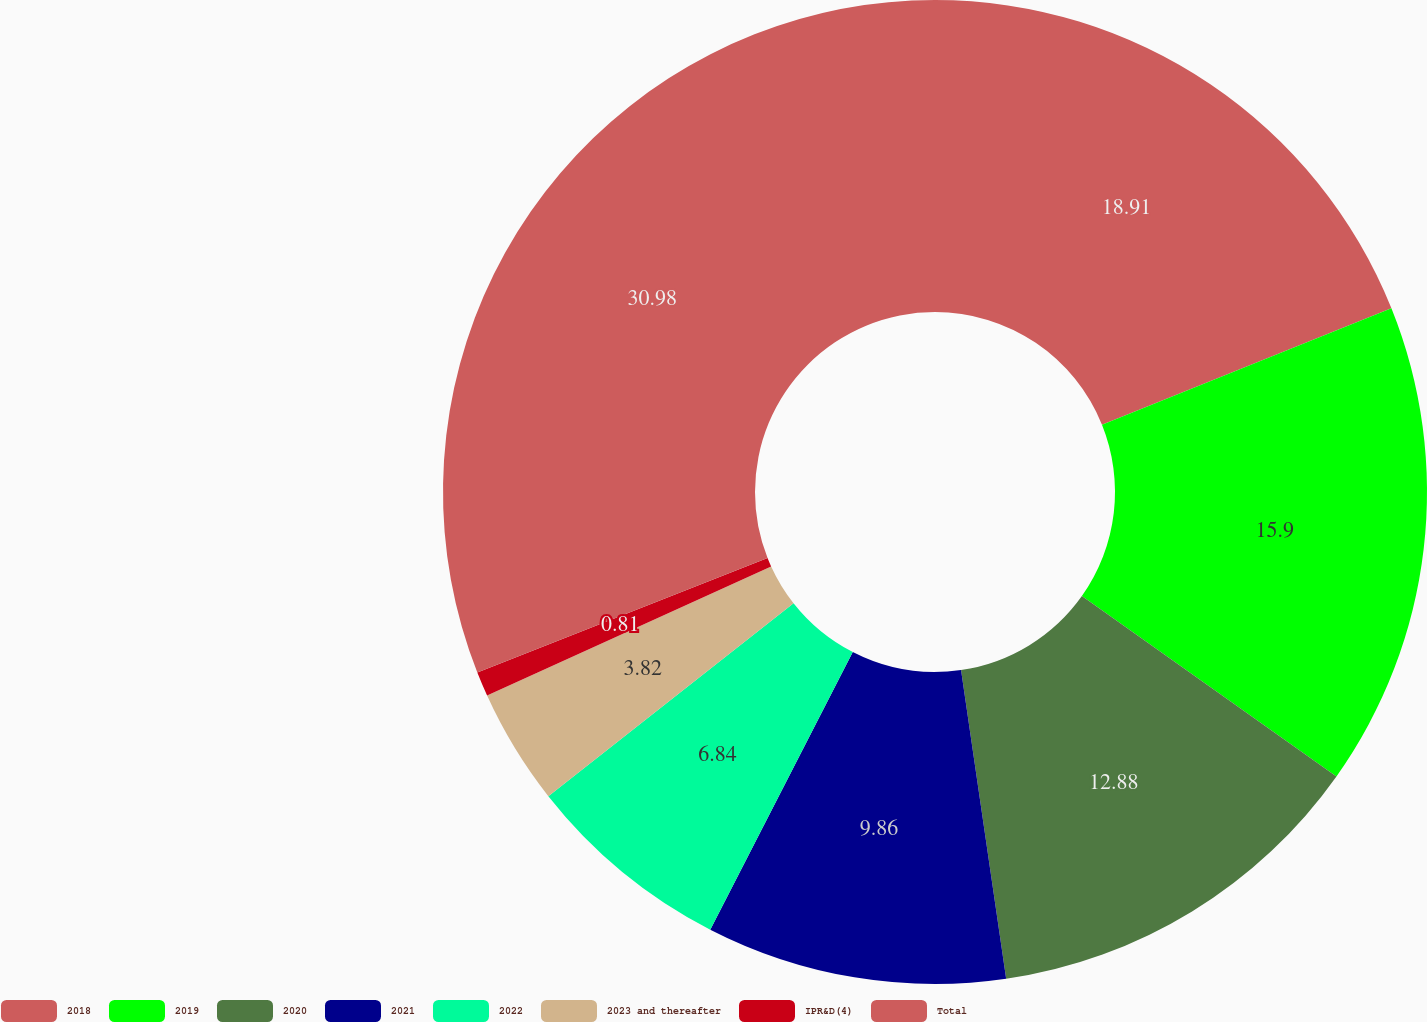Convert chart to OTSL. <chart><loc_0><loc_0><loc_500><loc_500><pie_chart><fcel>2018<fcel>2019<fcel>2020<fcel>2021<fcel>2022<fcel>2023 and thereafter<fcel>IPR&D(4)<fcel>Total<nl><fcel>18.91%<fcel>15.9%<fcel>12.88%<fcel>9.86%<fcel>6.84%<fcel>3.82%<fcel>0.81%<fcel>30.98%<nl></chart> 